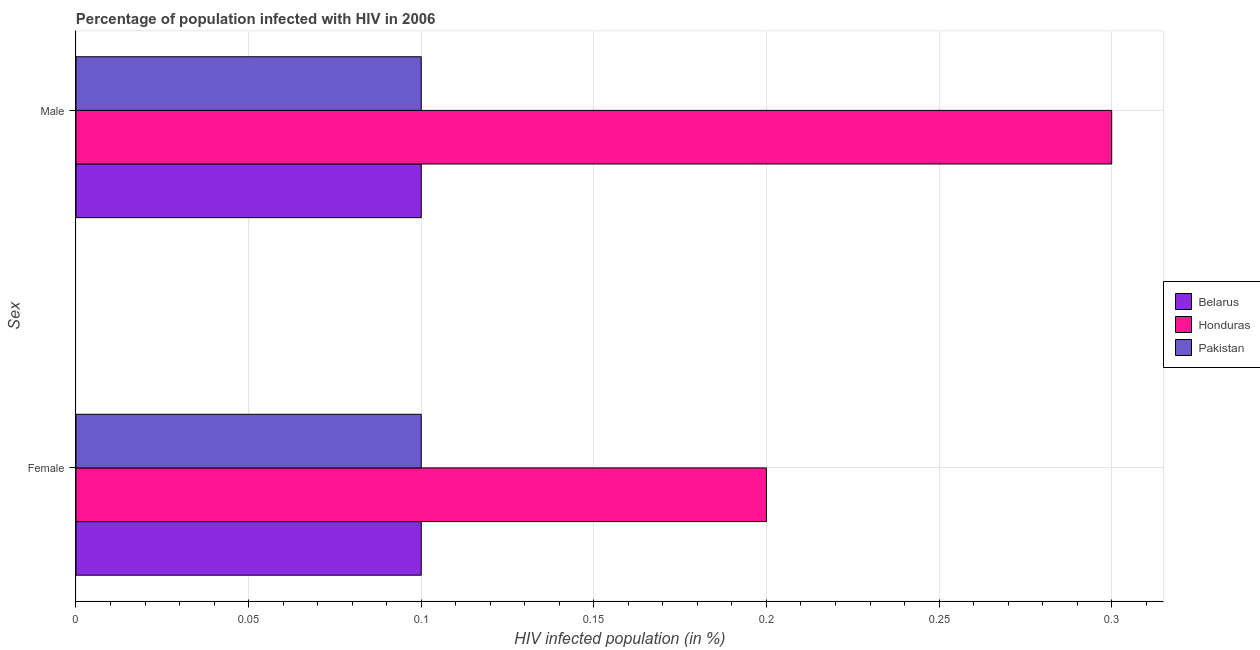Are the number of bars on each tick of the Y-axis equal?
Your answer should be very brief. Yes. Across all countries, what is the minimum percentage of females who are infected with hiv?
Keep it short and to the point. 0.1. In which country was the percentage of females who are infected with hiv maximum?
Make the answer very short. Honduras. In which country was the percentage of males who are infected with hiv minimum?
Your answer should be very brief. Belarus. What is the total percentage of males who are infected with hiv in the graph?
Your answer should be compact. 0.5. What is the average percentage of males who are infected with hiv per country?
Make the answer very short. 0.17. In how many countries, is the percentage of males who are infected with hiv greater than 0.22 %?
Provide a succinct answer. 1. What is the ratio of the percentage of males who are infected with hiv in Pakistan to that in Belarus?
Ensure brevity in your answer.  1. Is the percentage of males who are infected with hiv in Honduras less than that in Pakistan?
Keep it short and to the point. No. What does the 3rd bar from the top in Female represents?
Give a very brief answer. Belarus. What does the 2nd bar from the bottom in Female represents?
Keep it short and to the point. Honduras. What is the difference between two consecutive major ticks on the X-axis?
Give a very brief answer. 0.05. Where does the legend appear in the graph?
Offer a terse response. Center right. How are the legend labels stacked?
Provide a short and direct response. Vertical. What is the title of the graph?
Offer a very short reply. Percentage of population infected with HIV in 2006. What is the label or title of the X-axis?
Offer a terse response. HIV infected population (in %). What is the label or title of the Y-axis?
Make the answer very short. Sex. What is the HIV infected population (in %) of Pakistan in Female?
Offer a very short reply. 0.1. What is the HIV infected population (in %) in Honduras in Male?
Provide a short and direct response. 0.3. What is the HIV infected population (in %) in Pakistan in Male?
Your answer should be compact. 0.1. Across all Sex, what is the maximum HIV infected population (in %) of Honduras?
Your response must be concise. 0.3. What is the total HIV infected population (in %) in Belarus in the graph?
Your answer should be compact. 0.2. What is the total HIV infected population (in %) in Pakistan in the graph?
Your answer should be very brief. 0.2. What is the difference between the HIV infected population (in %) in Belarus in Female and that in Male?
Ensure brevity in your answer.  0. What is the difference between the HIV infected population (in %) in Honduras in Female and that in Male?
Give a very brief answer. -0.1. What is the difference between the HIV infected population (in %) of Belarus in Female and the HIV infected population (in %) of Honduras in Male?
Offer a very short reply. -0.2. What is the difference between the HIV infected population (in %) of Belarus in Female and the HIV infected population (in %) of Pakistan in Male?
Make the answer very short. 0. What is the average HIV infected population (in %) in Honduras per Sex?
Ensure brevity in your answer.  0.25. What is the difference between the HIV infected population (in %) in Belarus and HIV infected population (in %) in Honduras in Female?
Your answer should be compact. -0.1. What is the difference between the HIV infected population (in %) of Belarus and HIV infected population (in %) of Honduras in Male?
Your answer should be very brief. -0.2. What is the ratio of the HIV infected population (in %) in Honduras in Female to that in Male?
Give a very brief answer. 0.67. What is the ratio of the HIV infected population (in %) of Pakistan in Female to that in Male?
Provide a succinct answer. 1. What is the difference between the highest and the second highest HIV infected population (in %) in Honduras?
Keep it short and to the point. 0.1. What is the difference between the highest and the lowest HIV infected population (in %) in Honduras?
Your answer should be very brief. 0.1. What is the difference between the highest and the lowest HIV infected population (in %) in Pakistan?
Offer a terse response. 0. 